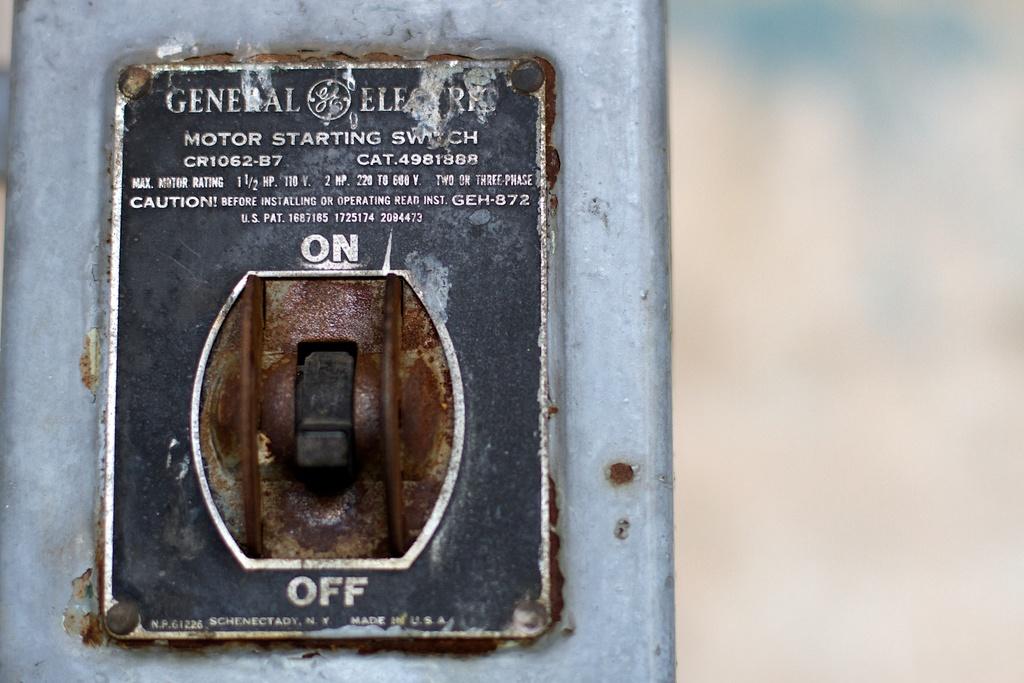Is it set to on or off?
Keep it short and to the point. Off. Which direction is off?
Offer a terse response. Down. 